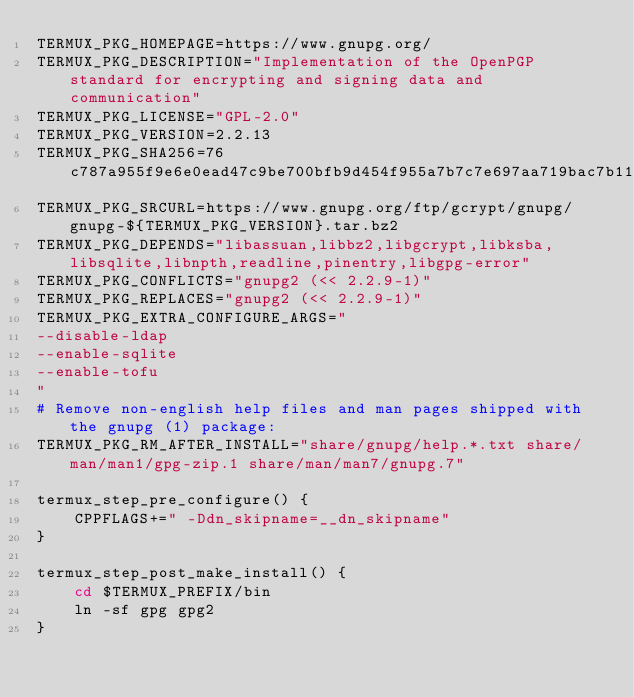Convert code to text. <code><loc_0><loc_0><loc_500><loc_500><_Bash_>TERMUX_PKG_HOMEPAGE=https://www.gnupg.org/
TERMUX_PKG_DESCRIPTION="Implementation of the OpenPGP standard for encrypting and signing data and communication"
TERMUX_PKG_LICENSE="GPL-2.0"
TERMUX_PKG_VERSION=2.2.13
TERMUX_PKG_SHA256=76c787a955f9e6e0ead47c9be700bfb9d454f955a7b7c7e697aa719bac7b11d8
TERMUX_PKG_SRCURL=https://www.gnupg.org/ftp/gcrypt/gnupg/gnupg-${TERMUX_PKG_VERSION}.tar.bz2
TERMUX_PKG_DEPENDS="libassuan,libbz2,libgcrypt,libksba,libsqlite,libnpth,readline,pinentry,libgpg-error"
TERMUX_PKG_CONFLICTS="gnupg2 (<< 2.2.9-1)"
TERMUX_PKG_REPLACES="gnupg2 (<< 2.2.9-1)"
TERMUX_PKG_EXTRA_CONFIGURE_ARGS="
--disable-ldap
--enable-sqlite
--enable-tofu
"
# Remove non-english help files and man pages shipped with the gnupg (1) package:
TERMUX_PKG_RM_AFTER_INSTALL="share/gnupg/help.*.txt share/man/man1/gpg-zip.1 share/man/man7/gnupg.7"

termux_step_pre_configure() {
	CPPFLAGS+=" -Ddn_skipname=__dn_skipname"
}

termux_step_post_make_install() {
	cd $TERMUX_PREFIX/bin
	ln -sf gpg gpg2
}
</code> 